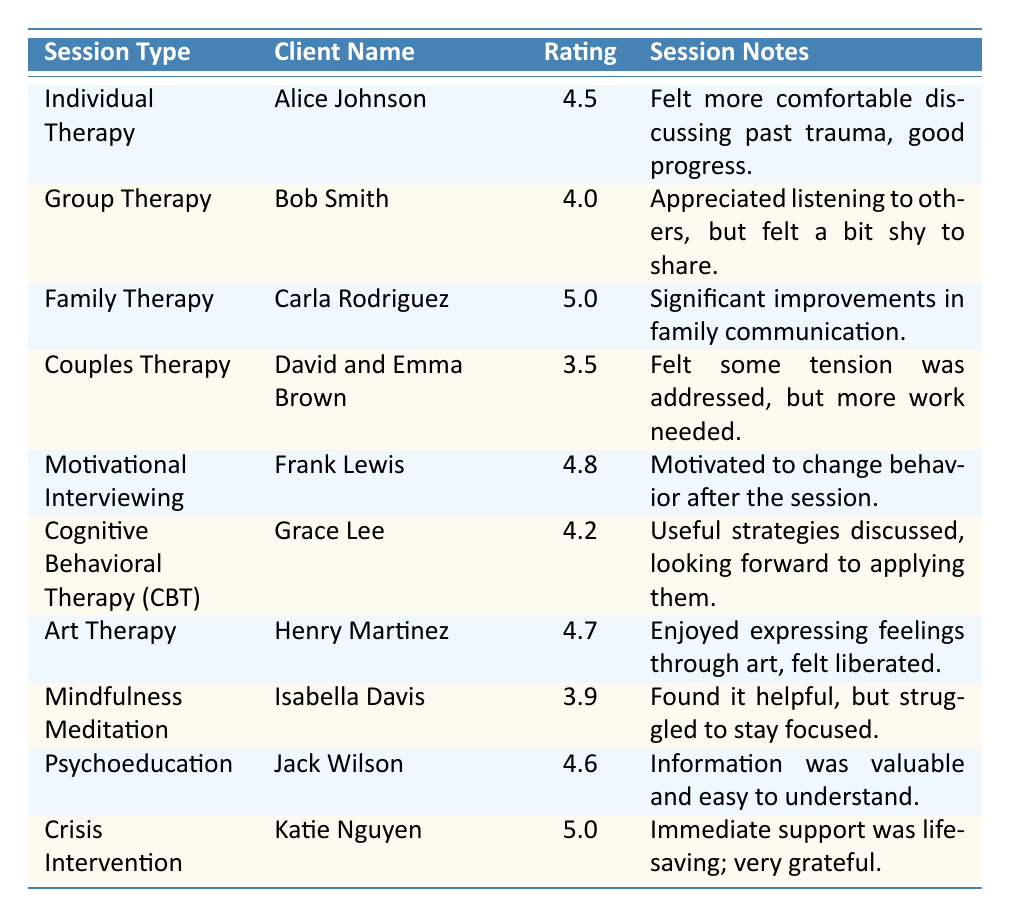What is the highest client feedback rating? The highest rating in the table is 5.0, given by Carla Rodriguez for Family Therapy and Katie Nguyen for Crisis Intervention.
Answer: 5.0 What was Alice Johnson's rating for Individual Therapy? The table shows that Alice Johnson received a rating of 4.5 for Individual Therapy.
Answer: 4.5 Which session type received the lowest rating? The lowest rating recorded in the table is 3.5 for Couples Therapy, given by David and Emma Brown.
Answer: Couples Therapy What is the average rating for all therapy sessions listed? To calculate the average, sum the ratings (4.5 + 4.0 + 5.0 + 3.5 + 4.8 + 4.2 + 4.7 + 3.9 + 4.6 + 5.0) = 46.2. There are 10 sessions, so the average is 46.2 / 10 = 4.62.
Answer: 4.62 Did any client express dissatisfaction during their session? Yes, David and Emma Brown expressed that while some tension was addressed in Couples Therapy, they felt more work was needed.
Answer: Yes Which session type had the greatest number of ratings over 4.0? The data shows that Individual Therapy, Family Therapy, Motivational Interviewing, Art Therapy, Psychoeducation, and Crisis Intervention all had ratings over 4.0. There are 6 such sessions.
Answer: 6 What percentage of ratings were above 4.5? The ratings above 4.5 are 4.8 (Motivational Interviewing), 4.7 (Art Therapy), 5.0 (Family Therapy), and 5.0 (Crisis Intervention) totaling 4 sessions. Therefore, (4 / 10) * 100 = 40%.
Answer: 40% Which client felt motivated to change their behavior? Frank Lewis noted feeling motivated to change his behavior after the session of Motivational Interviewing, which is highlighted in the notes.
Answer: Frank Lewis What notes did Isabella Davis provide for Mindfulness Meditation? Isabella Davis mentioned that she found mindfulness meditation helpful but struggled to stay focused based on her feedback notes in the table.
Answer: She found it helpful, but struggled to stay focused 